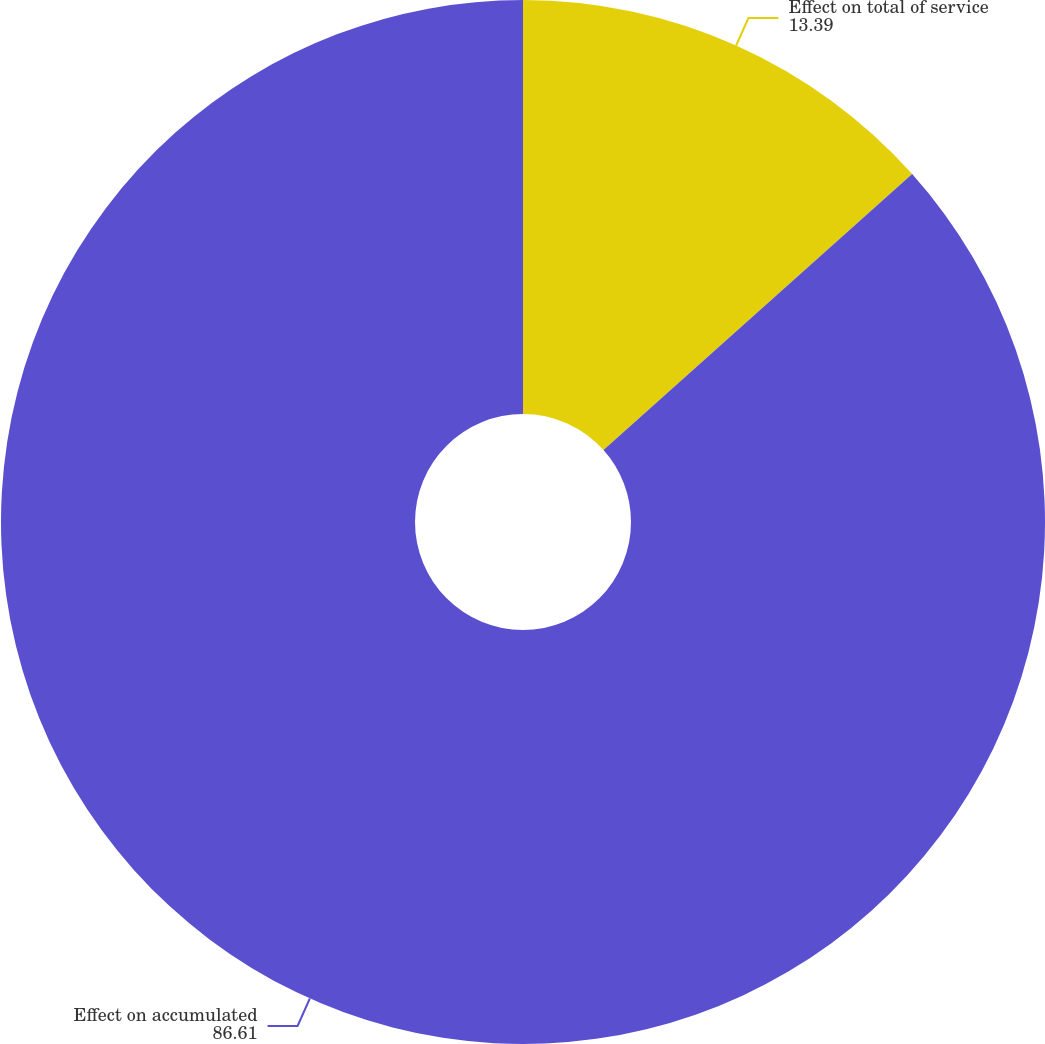<chart> <loc_0><loc_0><loc_500><loc_500><pie_chart><fcel>Effect on total of service<fcel>Effect on accumulated<nl><fcel>13.39%<fcel>86.61%<nl></chart> 